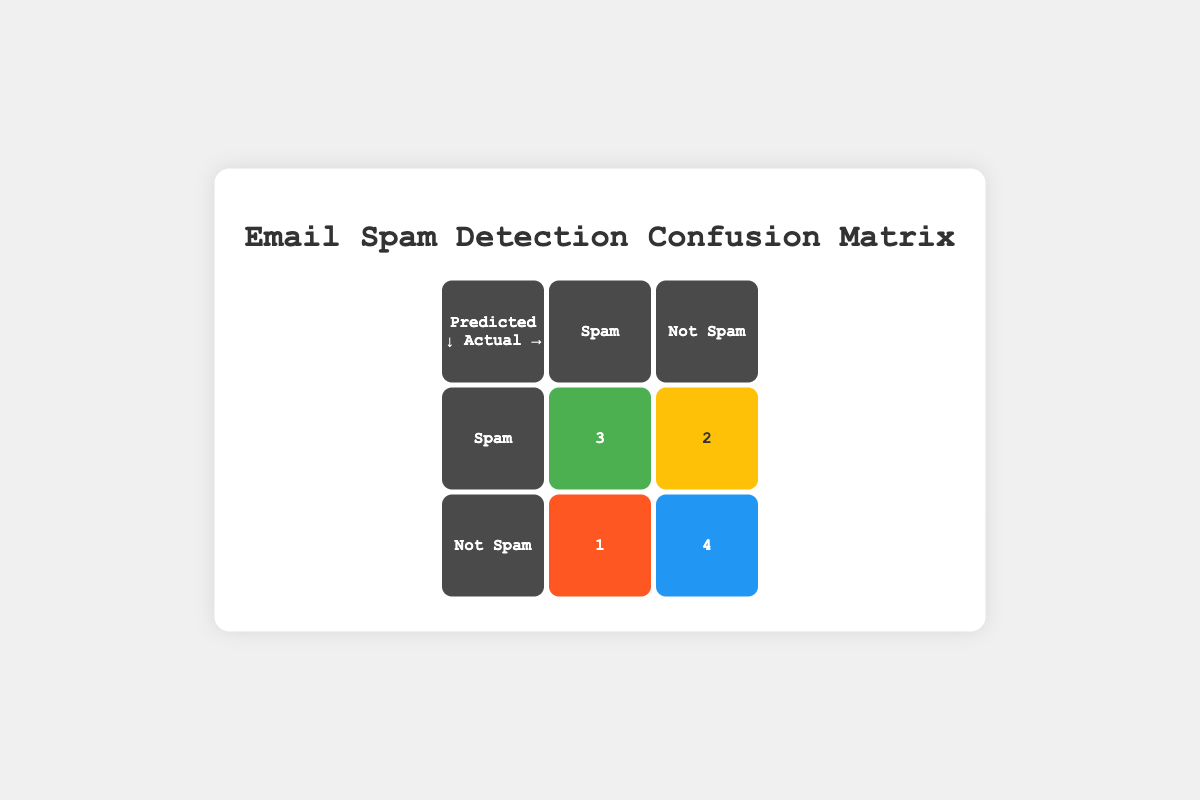What is the number of true positives in the matrix? The true positives represent the emails correctly identified as spam. In the matrix, true positives are located where both predicted and actual labels are "Spam," resulting in a count of 3.
Answer: 3 How many emails were incorrectly flagged as spam (false positives)? False positives occur when an email is predicted as spam, but it is actually not spam. The matrix shows 2 emails in this category.
Answer: 2 What is the total number of emails classified in the Confusion Matrix? The total number of emails can be determined by summing all the entries in the matrix. This includes true positives (3) + false positives (2) + false negatives (1) + true negatives (4), totaling 10 emails.
Answer: 10 What percentage of emails were correctly classified as not spam (true negatives)? True negatives are those that were both predicted and actually "Not Spam". In the matrix, there are 4 true negatives out of 10 total emails. To find the percentage, divide 4 by 10 and multiply by 100, leading to 40%.
Answer: 40% What is the difference between the number of true negatives and false negatives? True negatives (4) represent the correctly identified not spam emails, while false negatives (1) represent the spam emails that were wrongly classified as not spam. The difference is calculated as 4 - 1, resulting in 3.
Answer: 3 Is it true that all spam emails were detected correctly? To check if all spam emails were detected correctly, we need to look at true positives (3) and false negatives (1). The presence of false negatives indicates that at least one spam email was not detected, making the statement false.
Answer: No How many more true positives are there than false negatives? True positives are 3, and false negatives are 1. The difference is calculated as 3 - 1, resulting in 2 more true positives than false negatives.
Answer: 2 If we consider only the "Not Spam" emails, what fraction was correctly classified? The correctly classified not spam emails are true negatives (4). The total number of not spam emails is true negatives (4) plus false negatives (1), which equals 5. The fraction is 4/5, or 0.8 when expressed as a decimal.
Answer: 0.8 